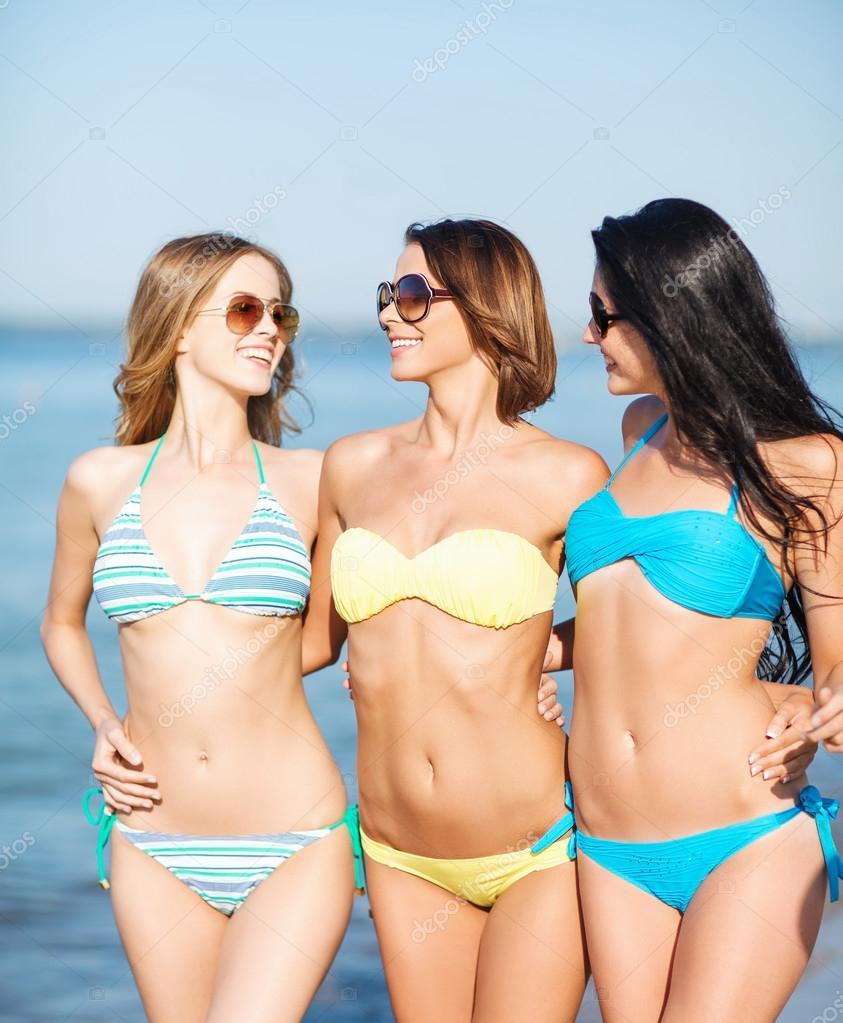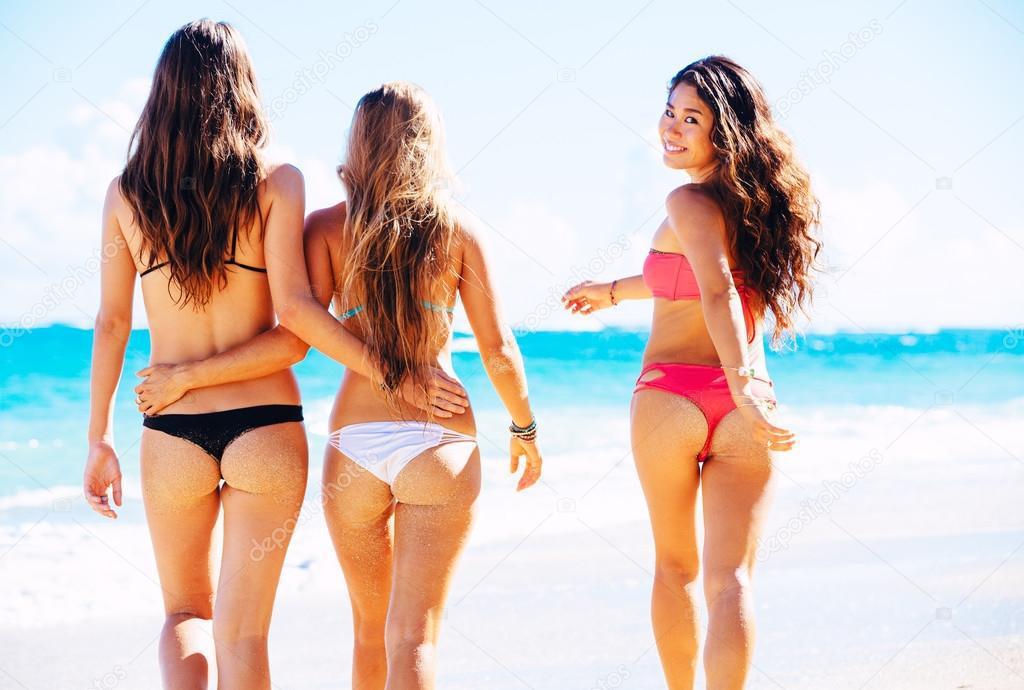The first image is the image on the left, the second image is the image on the right. Given the left and right images, does the statement "Three forward-facing bikini models are in the left image, and three rear-facing bikini models are in the right image." hold true? Answer yes or no. Yes. The first image is the image on the left, the second image is the image on the right. For the images displayed, is the sentence "There is a total of six women in bikinis." factually correct? Answer yes or no. Yes. 